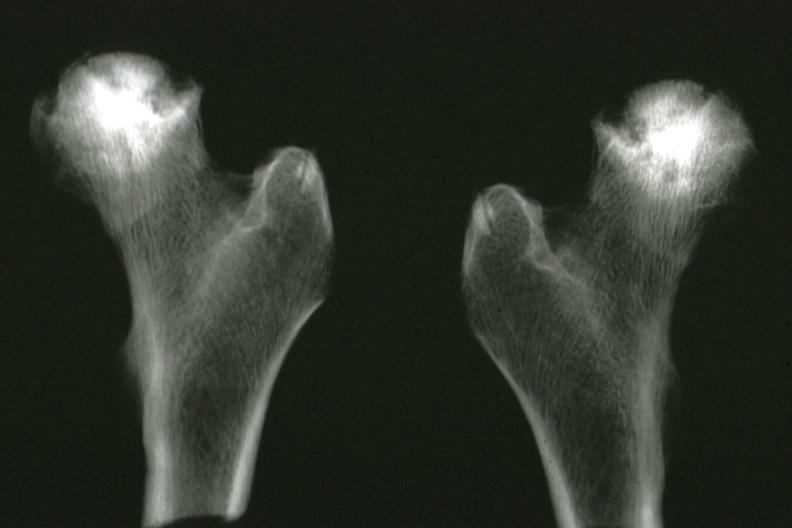what does this image show?
Answer the question using a single word or phrase. X-ray of femoral heads removed at autopsy good illustration 